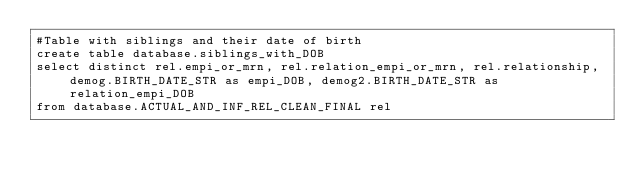Convert code to text. <code><loc_0><loc_0><loc_500><loc_500><_SQL_>#Table with siblings and their date of birth
create table database.siblings_with_DOB
select distinct rel.empi_or_mrn, rel.relation_empi_or_mrn, rel.relationship, demog.BIRTH_DATE_STR as empi_DOB, demog2.BIRTH_DATE_STR as relation_empi_DOB
from database.ACTUAL_AND_INF_REL_CLEAN_FINAL rel</code> 